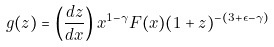Convert formula to latex. <formula><loc_0><loc_0><loc_500><loc_500>g ( z ) = \left ( \frac { d z } { d x } \right ) x ^ { 1 - \gamma } F ( x ) ( 1 + z ) ^ { - ( 3 + \epsilon - \gamma ) }</formula> 